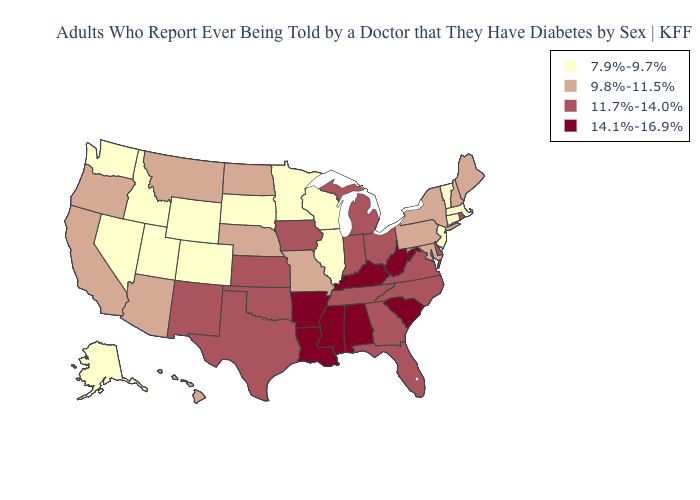Is the legend a continuous bar?
Be succinct. No. What is the lowest value in the South?
Short answer required. 9.8%-11.5%. Name the states that have a value in the range 14.1%-16.9%?
Concise answer only. Alabama, Arkansas, Kentucky, Louisiana, Mississippi, South Carolina, West Virginia. Name the states that have a value in the range 7.9%-9.7%?
Concise answer only. Alaska, Colorado, Connecticut, Idaho, Illinois, Massachusetts, Minnesota, Nevada, New Jersey, South Dakota, Utah, Vermont, Washington, Wisconsin, Wyoming. What is the value of Mississippi?
Answer briefly. 14.1%-16.9%. Name the states that have a value in the range 11.7%-14.0%?
Be succinct. Delaware, Florida, Georgia, Indiana, Iowa, Kansas, Michigan, New Mexico, North Carolina, Ohio, Oklahoma, Rhode Island, Tennessee, Texas, Virginia. Among the states that border Massachusetts , which have the highest value?
Short answer required. Rhode Island. Does Georgia have a higher value than Indiana?
Keep it brief. No. How many symbols are there in the legend?
Keep it brief. 4. Does Indiana have a higher value than Idaho?
Concise answer only. Yes. Does Wyoming have the highest value in the West?
Write a very short answer. No. Which states have the lowest value in the USA?
Answer briefly. Alaska, Colorado, Connecticut, Idaho, Illinois, Massachusetts, Minnesota, Nevada, New Jersey, South Dakota, Utah, Vermont, Washington, Wisconsin, Wyoming. Does California have the same value as Maryland?
Quick response, please. Yes. Name the states that have a value in the range 14.1%-16.9%?
Be succinct. Alabama, Arkansas, Kentucky, Louisiana, Mississippi, South Carolina, West Virginia. 